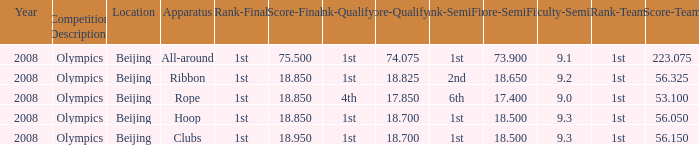What was her final score on the ribbon apparatus? 18.85. 